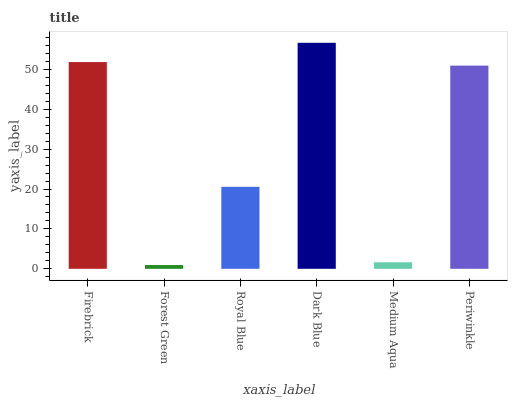Is Forest Green the minimum?
Answer yes or no. Yes. Is Dark Blue the maximum?
Answer yes or no. Yes. Is Royal Blue the minimum?
Answer yes or no. No. Is Royal Blue the maximum?
Answer yes or no. No. Is Royal Blue greater than Forest Green?
Answer yes or no. Yes. Is Forest Green less than Royal Blue?
Answer yes or no. Yes. Is Forest Green greater than Royal Blue?
Answer yes or no. No. Is Royal Blue less than Forest Green?
Answer yes or no. No. Is Periwinkle the high median?
Answer yes or no. Yes. Is Royal Blue the low median?
Answer yes or no. Yes. Is Medium Aqua the high median?
Answer yes or no. No. Is Firebrick the low median?
Answer yes or no. No. 